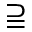Convert formula to latex. <formula><loc_0><loc_0><loc_500><loc_500>\supseteqq</formula> 